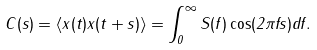<formula> <loc_0><loc_0><loc_500><loc_500>C ( s ) = \left < x ( t ) x ( t + s ) \right > = \int _ { 0 } ^ { \infty } S ( f ) \cos ( 2 \pi f s ) d f .</formula> 